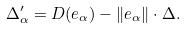<formula> <loc_0><loc_0><loc_500><loc_500>\Delta ^ { \prime } _ { \alpha } = D ( { e } _ { \alpha } ) - \| { e } _ { \alpha } \| \cdot \Delta .</formula> 